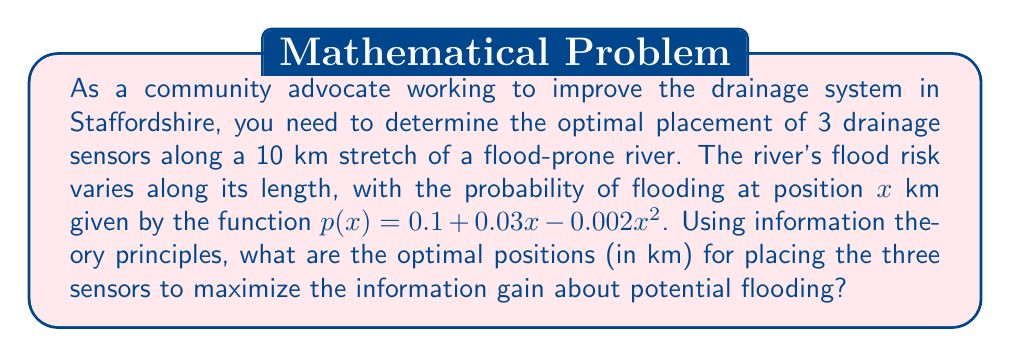Show me your answer to this math problem. To solve this problem, we'll use the principle of maximum entropy from information theory. The goal is to place the sensors where they will provide the most information about the flooding risk.

1) First, we need to normalize the probability function to ensure it integrates to 1 over the range [0, 10]:

   $$\int_0^{10} (0.1 + 0.03x - 0.002x^2) dx = 1$$

   This gives us a normalization constant $k$:

   $$k(0.1x + 0.015x^2 - \frac{2}{3000}x^3)|_0^{10} = 1$$
   $$k(1 + 1.5 - \frac{2}{3}) = 1$$
   $$k = \frac{1}{1.833} \approx 0.545$$

2) The normalized probability density function is:

   $$f(x) = 0.545(0.1 + 0.03x - 0.002x^2)$$

3) To maximize information gain, we want to divide the area under this curve into three equal parts. This is because each sensor should provide an equal amount of information.

4) We need to find points $a$ and $b$ such that:

   $$\int_0^a f(x)dx = \int_a^b f(x)dx = \int_b^{10} f(x)dx = \frac{1}{3}$$

5) Solving these integrals numerically (as they're complex to solve analytically), we get:

   $a \approx 2.76$ km
   $b \approx 6.24$ km

6) Therefore, the optimal positions for the three sensors are at approximately 2.76 km, 6.24 km, and at one of the endpoints (0 km or 10 km). Since the probability of flooding is higher at 10 km than at 0 km, we choose 10 km for the third sensor.
Answer: The optimal positions for placing the three sensors are approximately 2.76 km, 6.24 km, and 10 km along the 10 km stretch of the river. 